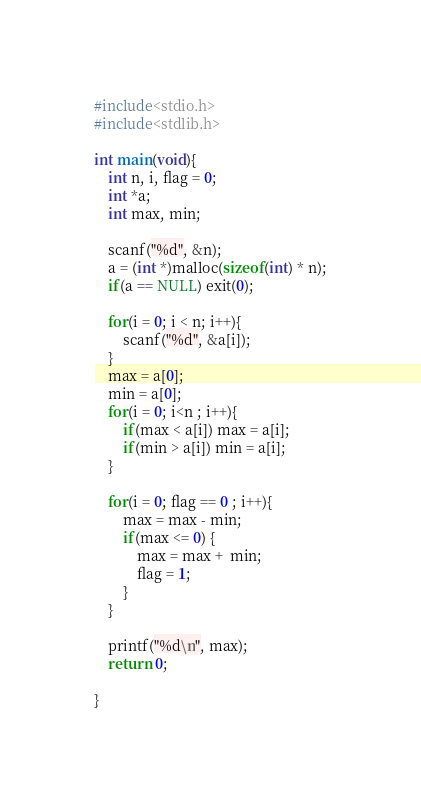<code> <loc_0><loc_0><loc_500><loc_500><_C_>#include<stdio.h>
#include<stdlib.h>

int main(void){
    int n, i, flag = 0;
    int *a;
    int max, min;

    scanf("%d", &n);
    a = (int *)malloc(sizeof(int) * n);
    if(a == NULL) exit(0);

    for(i = 0; i < n; i++){
        scanf("%d", &a[i]);
    }
    max = a[0];
    min = a[0];
    for(i = 0; i<n ; i++){
        if(max < a[i]) max = a[i];
        if(min > a[i]) min = a[i];
    }

    for(i = 0; flag == 0 ; i++){
        max = max - min;
        if(max <= 0) {
            max = max +  min;
            flag = 1;
        }
    }
    
    printf("%d\n", max);
    return 0;

}</code> 